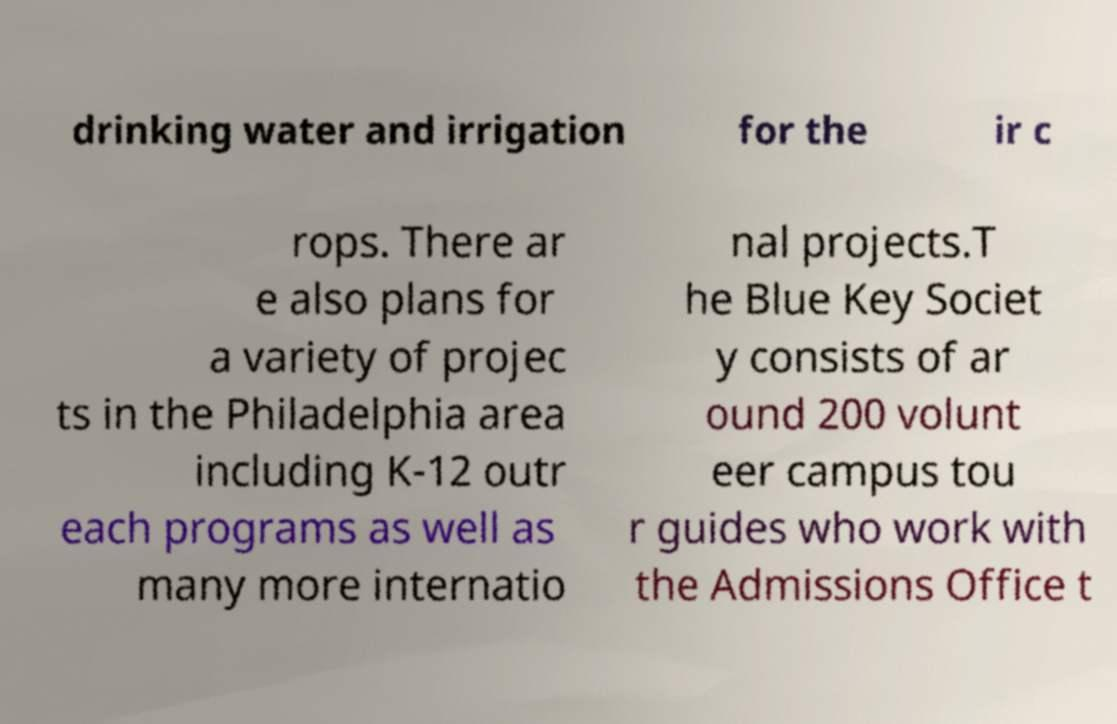Can you accurately transcribe the text from the provided image for me? drinking water and irrigation for the ir c rops. There ar e also plans for a variety of projec ts in the Philadelphia area including K-12 outr each programs as well as many more internatio nal projects.T he Blue Key Societ y consists of ar ound 200 volunt eer campus tou r guides who work with the Admissions Office t 